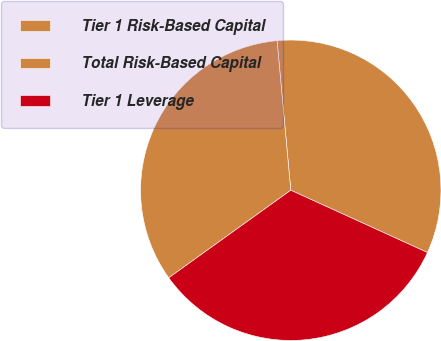Convert chart. <chart><loc_0><loc_0><loc_500><loc_500><pie_chart><fcel>Tier 1 Risk-Based Capital<fcel>Total Risk-Based Capital<fcel>Tier 1 Leverage<nl><fcel>33.26%<fcel>33.45%<fcel>33.28%<nl></chart> 